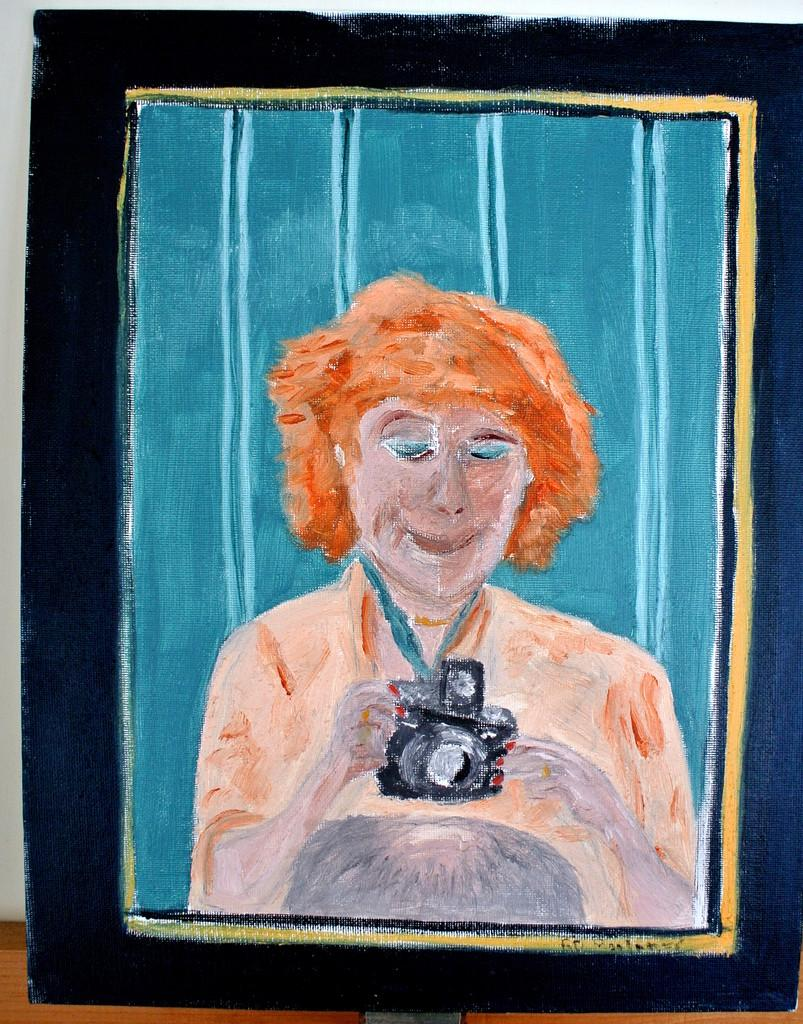What is the main subject of the image? The main subject of the image is a painting sheet. What is depicted in the painting on the sheet? The painting depicts a person holding a camera. What is the person in the painting doing? The person in the painting is looking at the camera. How many oranges are visible in the painting? There are no oranges depicted in the painting; it features a person holding a camera. What is the person's afterthought after looking at the camera in the painting? The provided facts do not mention any afterthoughts or emotions of the person in the painting. --- Facts: 1. There is a person sitting on a chair in the image. 2. The person is holding a book. 3. The book has a blue cover. 4. There is a table next to the chair. 5. A lamp is on the table. Absurd Topics: parrot, dance, mountain Conversation: What is the person in the image doing? The person in the image is sitting on a chair. What is the person holding in the image? The person is holding a book. What color is the book's cover? The book has a blue cover. What is located next to the chair in the image? There is a table next to the chair. What object is on the table in the image? A lamp is on the table. Reasoning: Let's think step by step in order to produce the conversation. We start by identifying the main subject of the image, which is the person sitting on a chair. Then, we describe the person's actions and the objects they are holding or interacting with, such as the book and the table. Finally, we mention the lamp on the table as an additional detail. Each question is designed to elicit a specific detail about the image that is known from the provided facts. Absurd Question/Answer: Can you see a parrot dancing on the mountain in the image? There is no parrot, dancing, or mountain present in the image; it features a person sitting on a chair holding a book. 